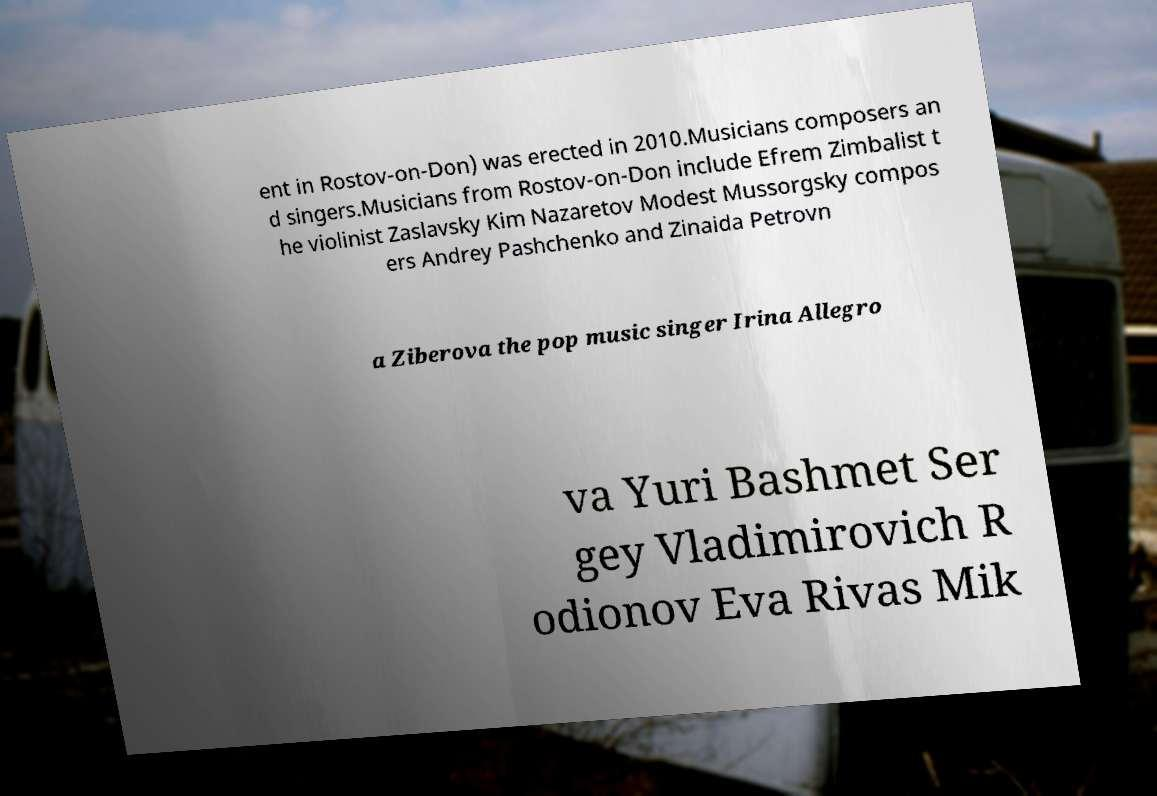What messages or text are displayed in this image? I need them in a readable, typed format. ent in Rostov-on-Don) was erected in 2010.Musicians composers an d singers.Musicians from Rostov-on-Don include Efrem Zimbalist t he violinist Zaslavsky Kim Nazaretov Modest Mussorgsky compos ers Andrey Pashchenko and Zinaida Petrovn a Ziberova the pop music singer Irina Allegro va Yuri Bashmet Ser gey Vladimirovich R odionov Eva Rivas Mik 